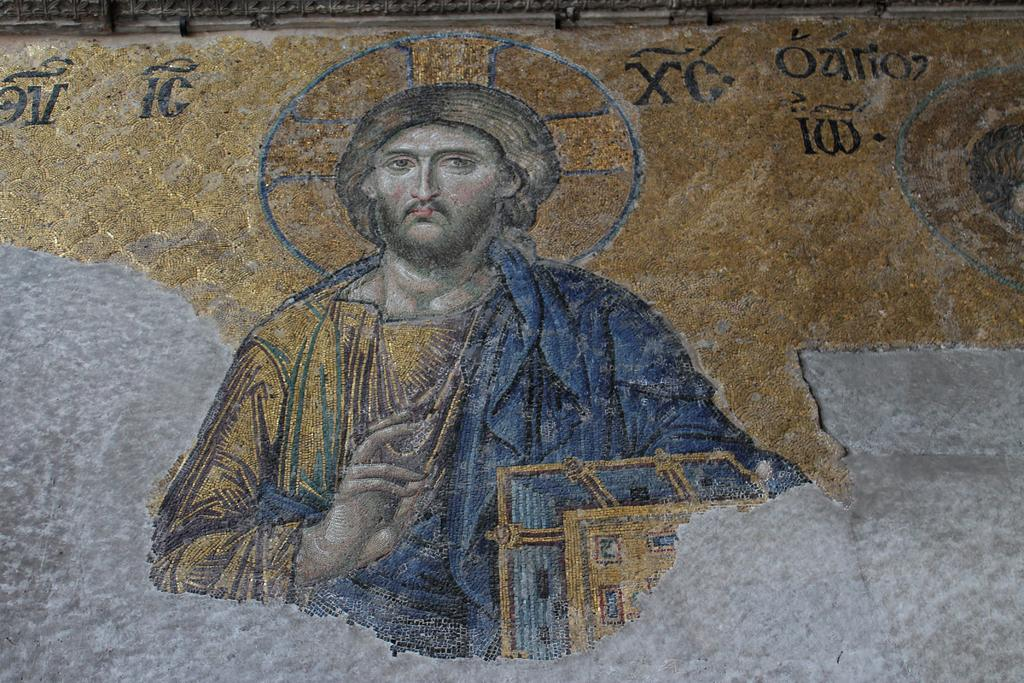What type of structure is visible in the image? There is a rock wall in the image. What is depicted on the rock wall? There is a painting of Jesus on the rock wall. What type of precipitation can be seen falling in the image? There is no precipitation visible in the image; it only features a rock wall with a painting of Jesus. What type of season is depicted in the image? The image does not depict a specific season, as it only features a rock wall with a painting of Jesus. 